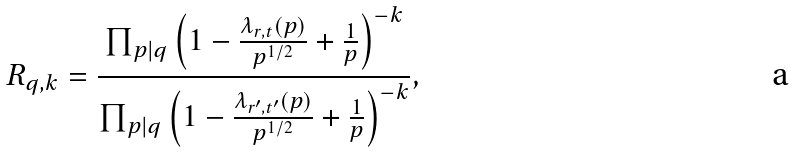<formula> <loc_0><loc_0><loc_500><loc_500>R _ { q , k } = \frac { \prod _ { \substack { p | q } } \left ( 1 - \frac { \lambda _ { r , t } ( p ) } { p ^ { 1 / 2 } } + \frac { 1 } { p } \right ) ^ { - k } } { \prod _ { p | q } \left ( 1 - \frac { \lambda _ { r ^ { \prime } , t ^ { \prime } } ( p ) } { p ^ { 1 / 2 } } + \frac { 1 } { p } \right ) ^ { - k } } ,</formula> 